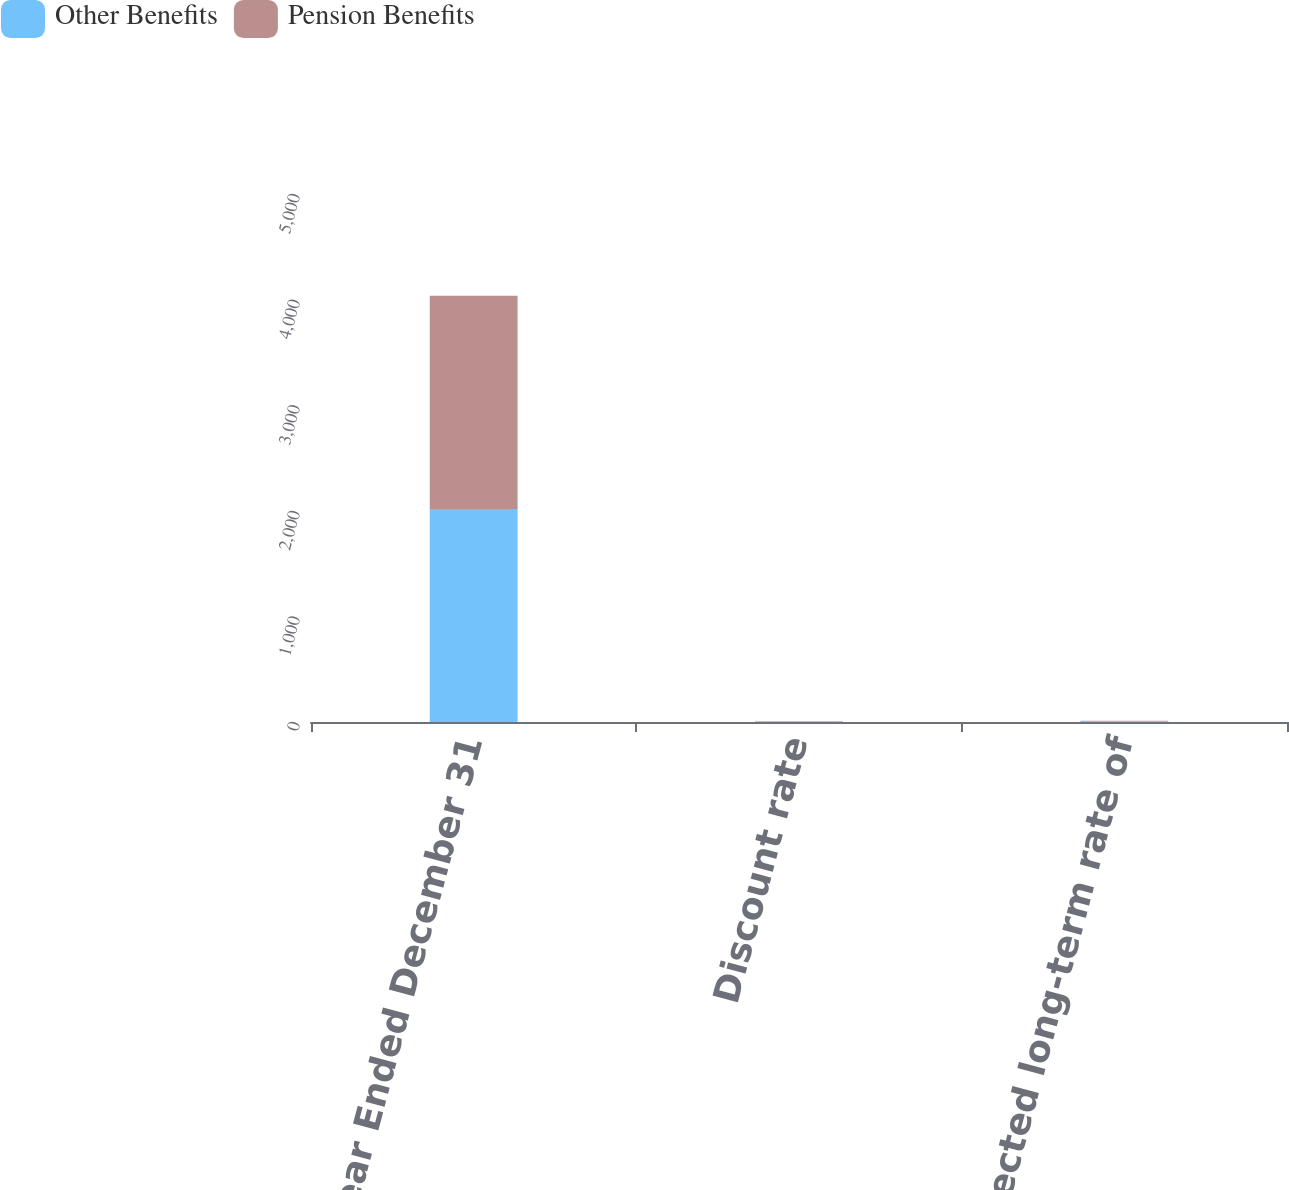Convert chart to OTSL. <chart><loc_0><loc_0><loc_500><loc_500><stacked_bar_chart><ecel><fcel>Year Ended December 31<fcel>Discount rate<fcel>Expected long-term rate of<nl><fcel>Other Benefits<fcel>2018<fcel>3.5<fcel>8<nl><fcel>Pension Benefits<fcel>2018<fcel>3.5<fcel>4.5<nl></chart> 